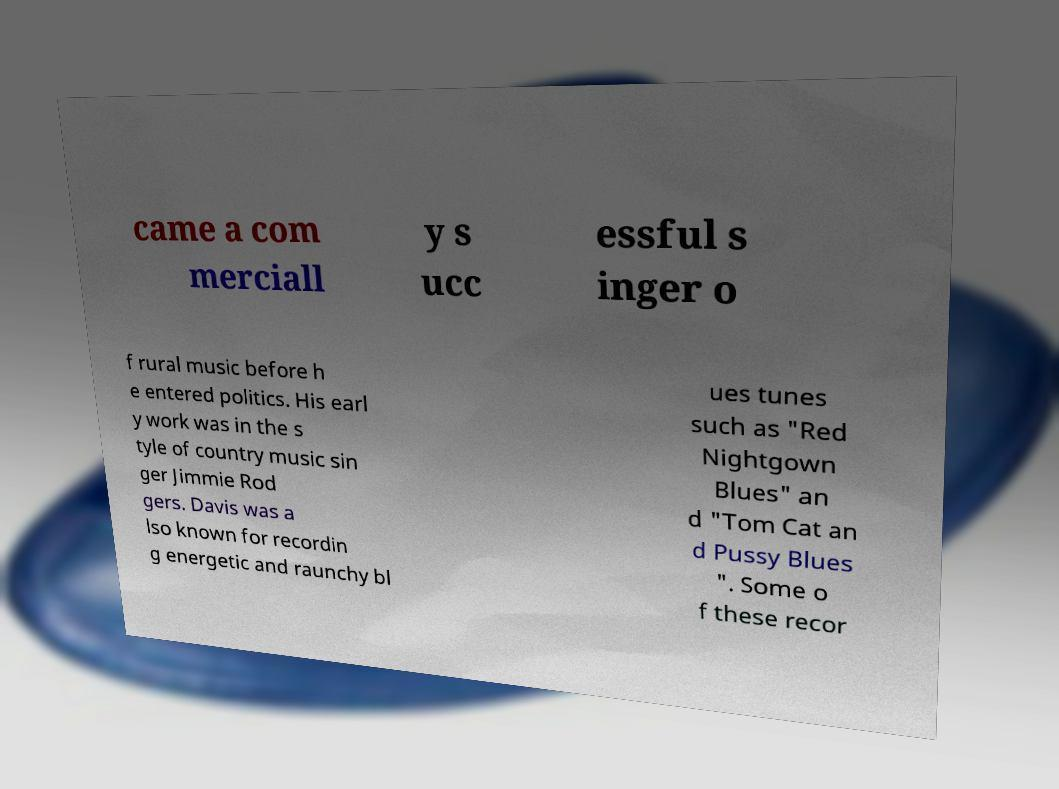Please read and relay the text visible in this image. What does it say? came a com merciall y s ucc essful s inger o f rural music before h e entered politics. His earl y work was in the s tyle of country music sin ger Jimmie Rod gers. Davis was a lso known for recordin g energetic and raunchy bl ues tunes such as "Red Nightgown Blues" an d "Tom Cat an d Pussy Blues ". Some o f these recor 